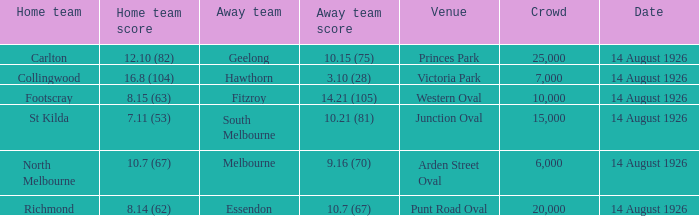What is the sum of all the crowds that watched North Melbourne at home? 6000.0. 